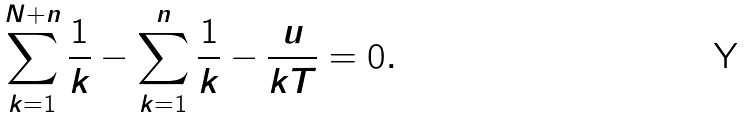Convert formula to latex. <formula><loc_0><loc_0><loc_500><loc_500>\sum _ { k = 1 } ^ { N + n } \frac { 1 } { k } - \sum _ { k = 1 } ^ { n } \frac { 1 } { k } - \frac { u } { k T } = 0 .</formula> 